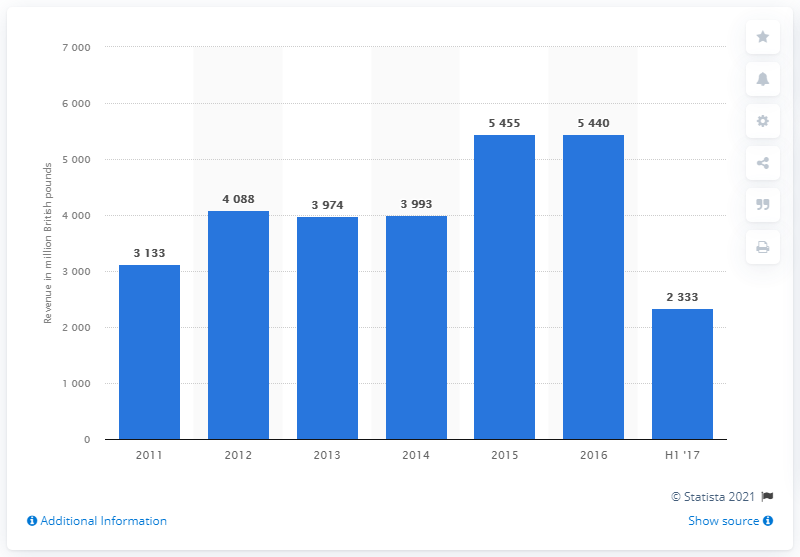List a handful of essential elements in this visual. Amec Foster Wheeler's revenue in 2016 was 5440. 